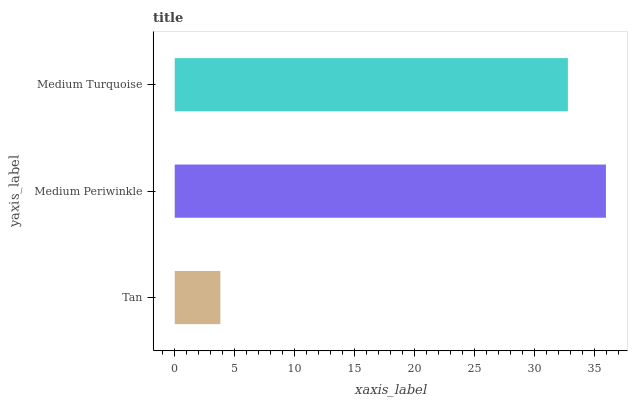Is Tan the minimum?
Answer yes or no. Yes. Is Medium Periwinkle the maximum?
Answer yes or no. Yes. Is Medium Turquoise the minimum?
Answer yes or no. No. Is Medium Turquoise the maximum?
Answer yes or no. No. Is Medium Periwinkle greater than Medium Turquoise?
Answer yes or no. Yes. Is Medium Turquoise less than Medium Periwinkle?
Answer yes or no. Yes. Is Medium Turquoise greater than Medium Periwinkle?
Answer yes or no. No. Is Medium Periwinkle less than Medium Turquoise?
Answer yes or no. No. Is Medium Turquoise the high median?
Answer yes or no. Yes. Is Medium Turquoise the low median?
Answer yes or no. Yes. Is Medium Periwinkle the high median?
Answer yes or no. No. Is Tan the low median?
Answer yes or no. No. 